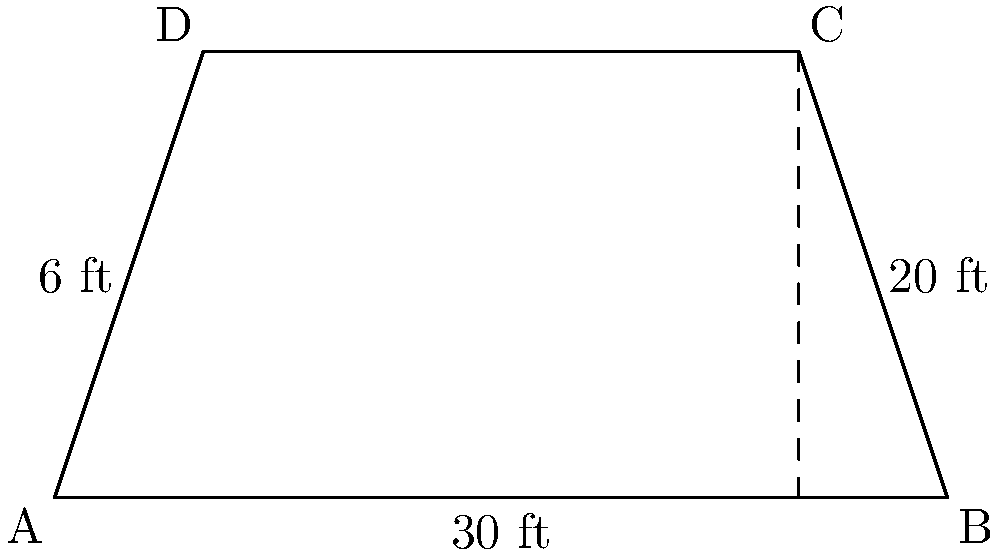You're planning a major rap concert and need to determine the area of the trapezoid-shaped stage. The stage has parallel sides of 30 ft and 20 ft, with a height of 6 ft between them. What is the total area of the stage in square feet? To find the area of a trapezoid, we use the formula:

$$A = \frac{1}{2}(b_1 + b_2)h$$

Where:
$A$ = Area
$b_1$ = Length of one parallel side
$b_2$ = Length of the other parallel side
$h$ = Height (perpendicular distance between parallel sides)

Given:
$b_1 = 30$ ft (bottom base)
$b_2 = 20$ ft (top base)
$h = 6$ ft

Let's plug these values into the formula:

$$A = \frac{1}{2}(30 + 20) \times 6$$

$$A = \frac{1}{2}(50) \times 6$$

$$A = 25 \times 6$$

$$A = 150$$

Therefore, the area of the trapezoid-shaped stage is 150 square feet.
Answer: 150 sq ft 